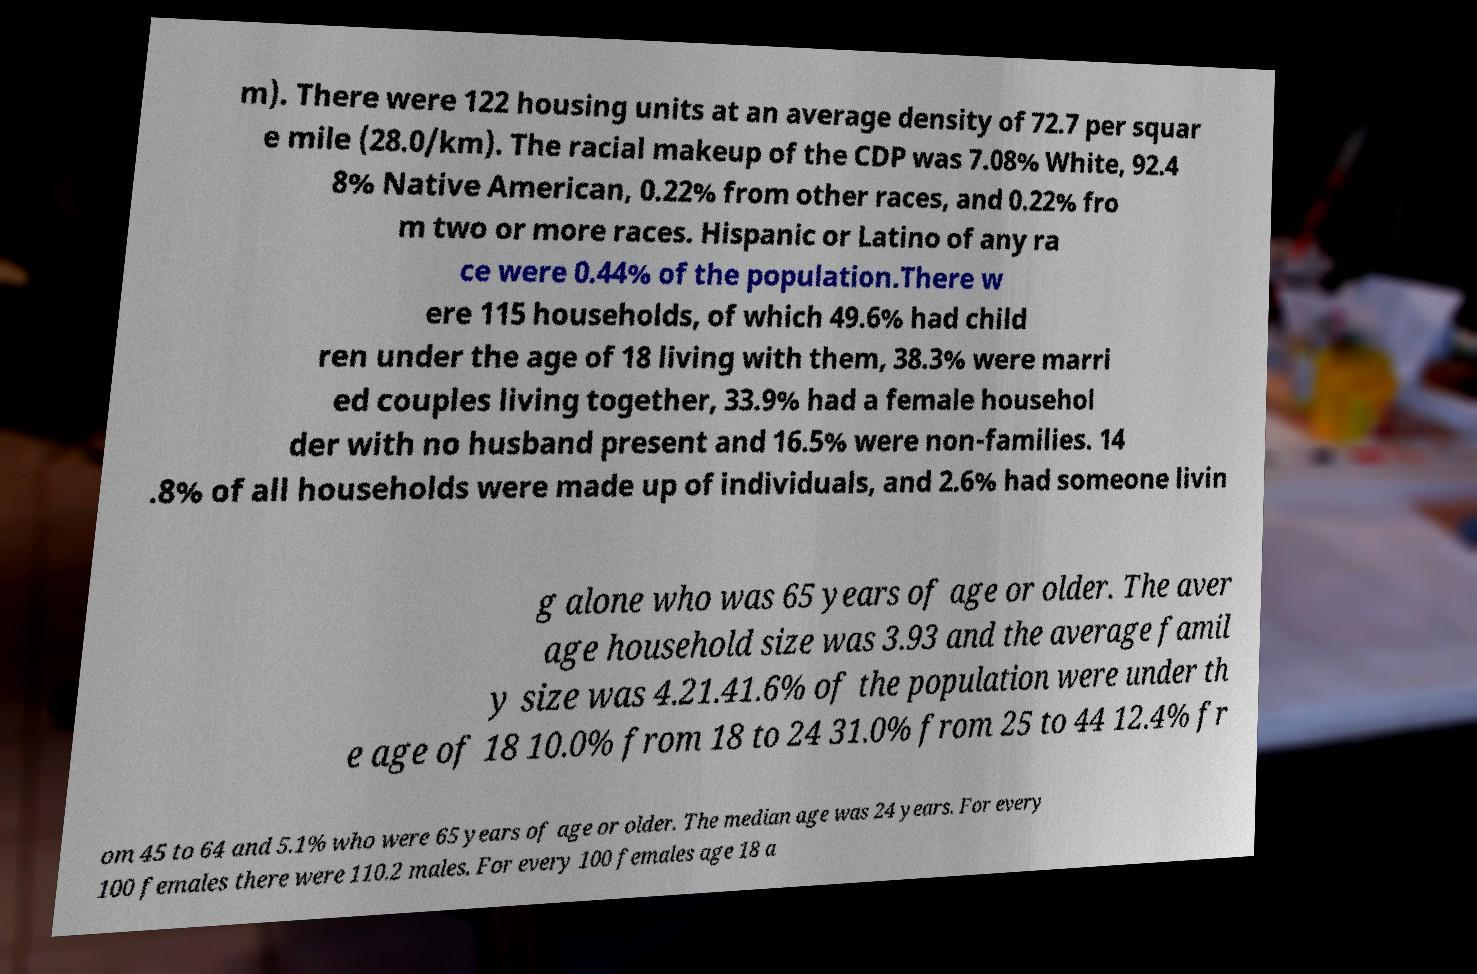For documentation purposes, I need the text within this image transcribed. Could you provide that? m). There were 122 housing units at an average density of 72.7 per squar e mile (28.0/km). The racial makeup of the CDP was 7.08% White, 92.4 8% Native American, 0.22% from other races, and 0.22% fro m two or more races. Hispanic or Latino of any ra ce were 0.44% of the population.There w ere 115 households, of which 49.6% had child ren under the age of 18 living with them, 38.3% were marri ed couples living together, 33.9% had a female househol der with no husband present and 16.5% were non-families. 14 .8% of all households were made up of individuals, and 2.6% had someone livin g alone who was 65 years of age or older. The aver age household size was 3.93 and the average famil y size was 4.21.41.6% of the population were under th e age of 18 10.0% from 18 to 24 31.0% from 25 to 44 12.4% fr om 45 to 64 and 5.1% who were 65 years of age or older. The median age was 24 years. For every 100 females there were 110.2 males. For every 100 females age 18 a 